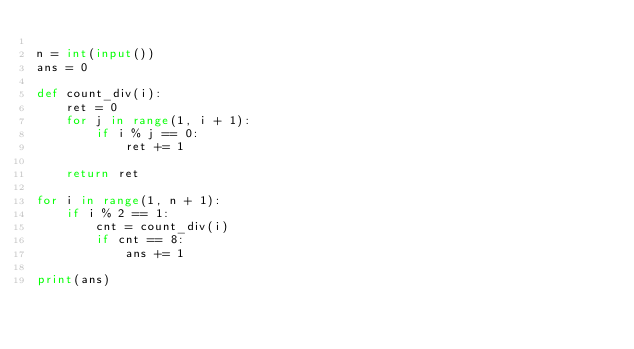Convert code to text. <code><loc_0><loc_0><loc_500><loc_500><_Python_>
n = int(input())
ans = 0

def count_div(i):
    ret = 0
    for j in range(1, i + 1):
        if i % j == 0:
            ret += 1
    
    return ret

for i in range(1, n + 1):
    if i % 2 == 1:
        cnt = count_div(i)
        if cnt == 8:
            ans += 1

print(ans)</code> 